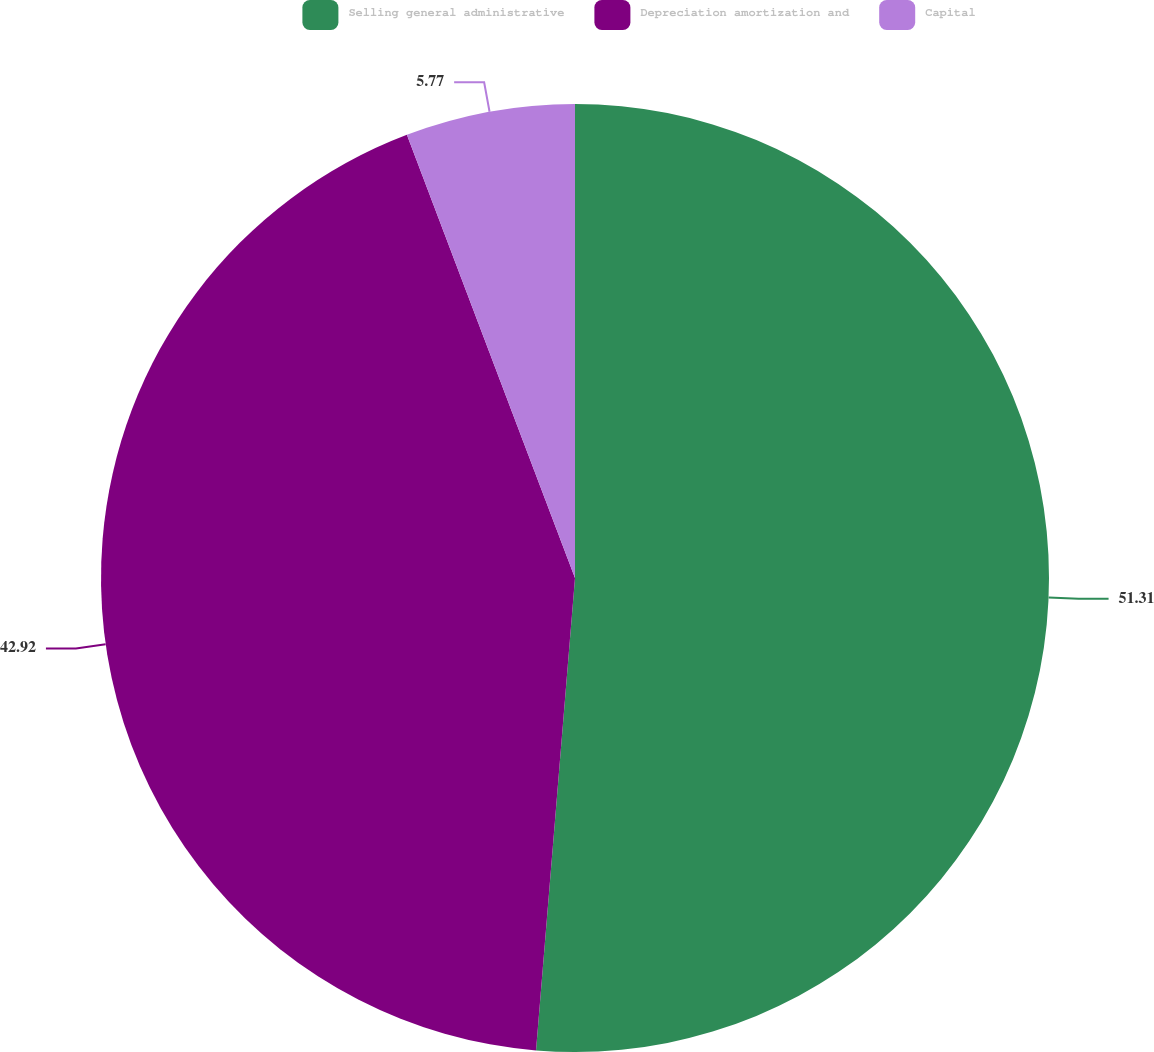Convert chart. <chart><loc_0><loc_0><loc_500><loc_500><pie_chart><fcel>Selling general administrative<fcel>Depreciation amortization and<fcel>Capital<nl><fcel>51.31%<fcel>42.92%<fcel>5.77%<nl></chart> 